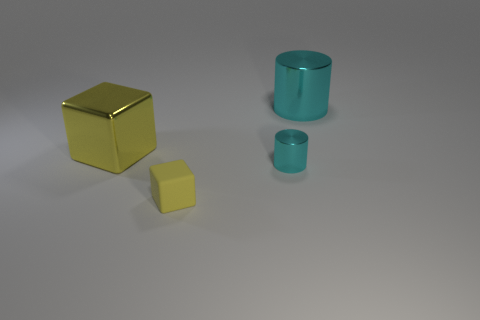Add 4 big cylinders. How many objects exist? 8 Subtract 0 red cylinders. How many objects are left? 4 Subtract all red cubes. Subtract all blue cylinders. How many cubes are left? 2 Subtract all large purple cylinders. Subtract all big yellow shiny cubes. How many objects are left? 3 Add 4 big cyan metal cylinders. How many big cyan metal cylinders are left? 5 Add 4 tiny things. How many tiny things exist? 6 